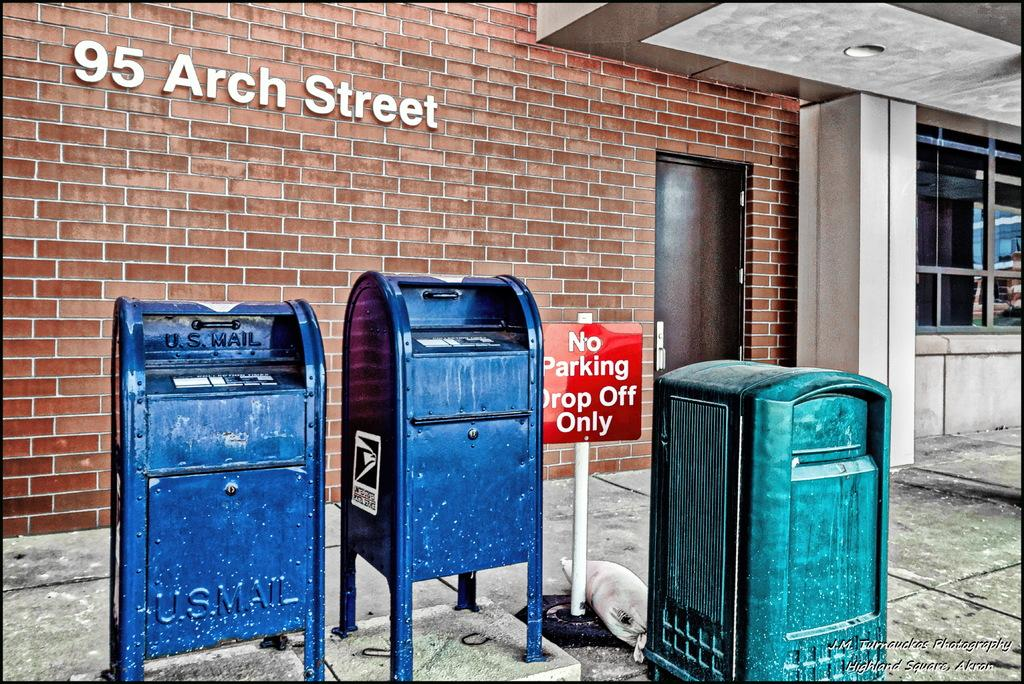<image>
Present a compact description of the photo's key features. A red No Parking sign is next to two blue post office's mailboxes. 